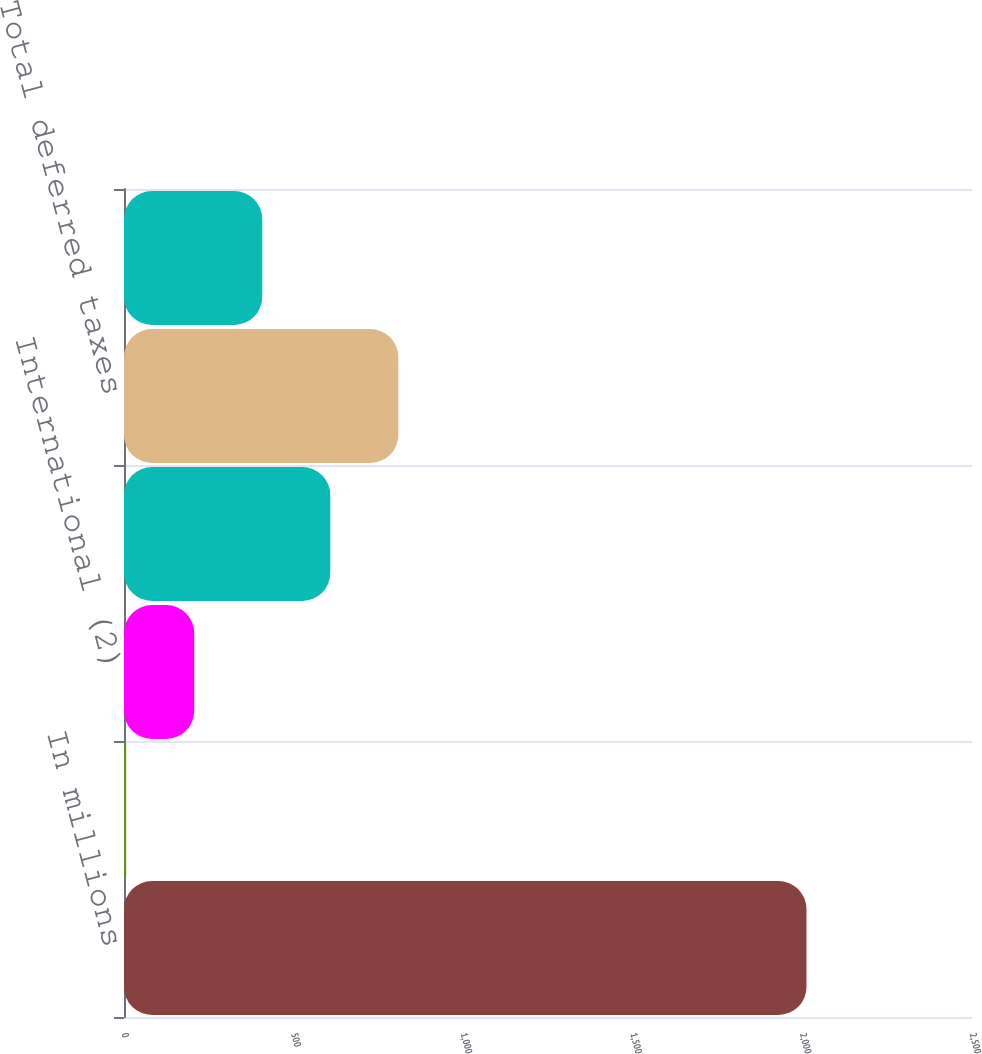Convert chart. <chart><loc_0><loc_0><loc_500><loc_500><bar_chart><fcel>In millions<fcel>Federal (1)<fcel>International (2)<fcel>Total current taxes<fcel>Total deferred taxes<fcel>Total provision (benefit) for<nl><fcel>2012<fcel>6.5<fcel>207.05<fcel>608.15<fcel>808.7<fcel>407.6<nl></chart> 